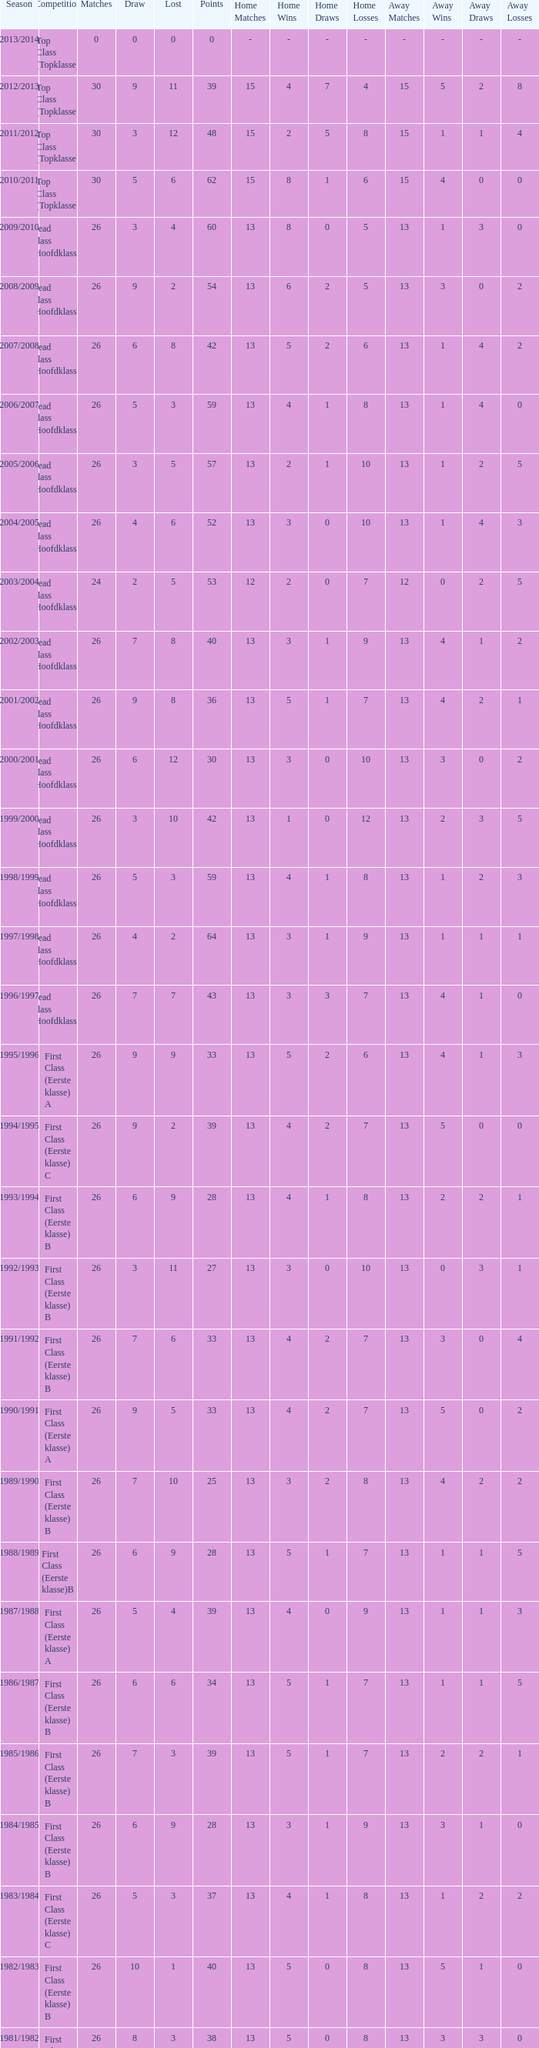What is the sum of the losses that a match score larger than 26, a points score of 62, and a draw greater than 5? None. 